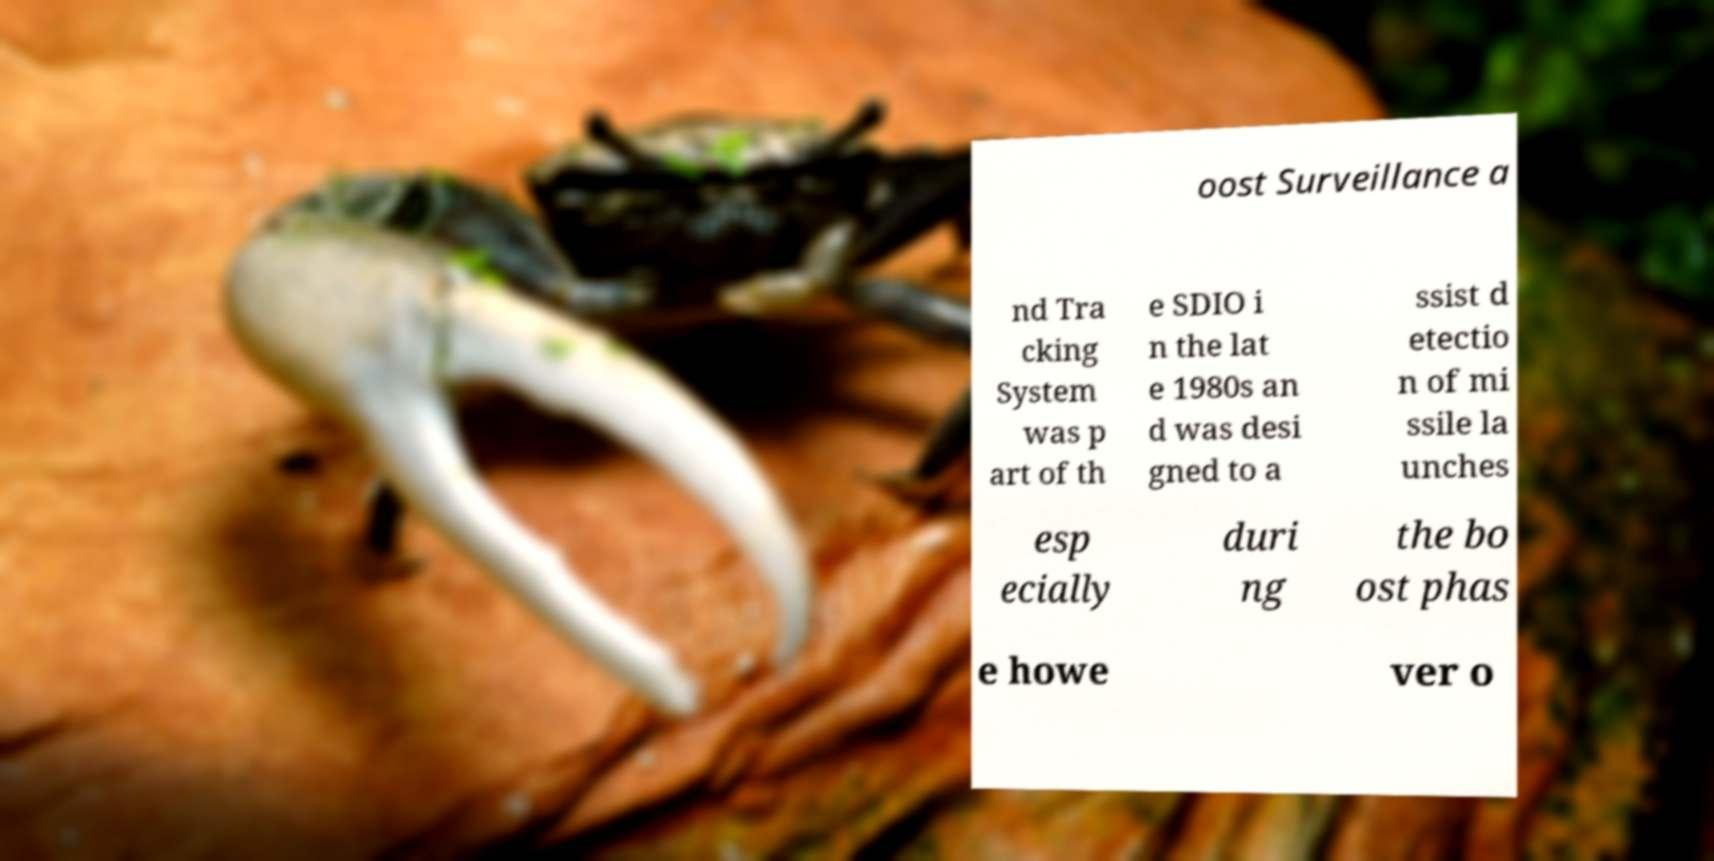There's text embedded in this image that I need extracted. Can you transcribe it verbatim? oost Surveillance a nd Tra cking System was p art of th e SDIO i n the lat e 1980s an d was desi gned to a ssist d etectio n of mi ssile la unches esp ecially duri ng the bo ost phas e howe ver o 